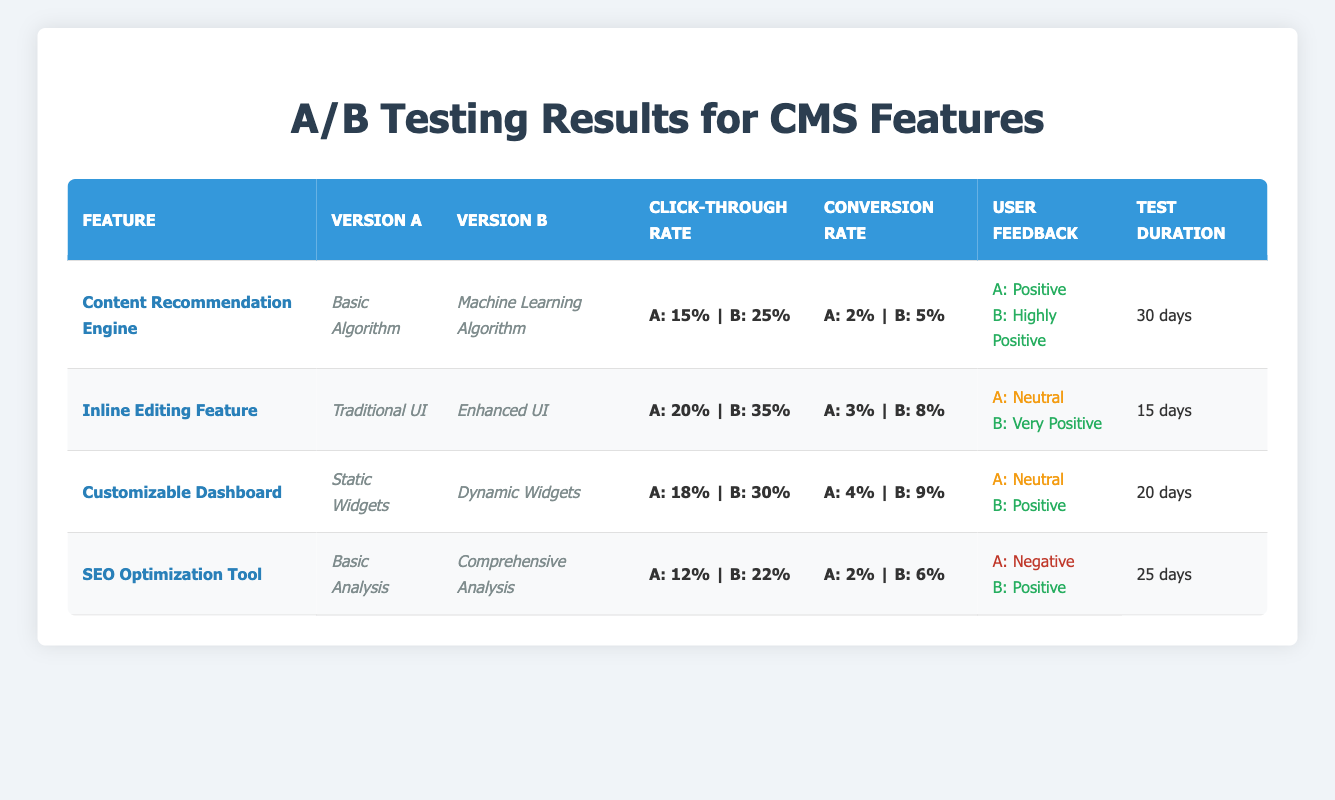What is the click-through rate for version B of the Content Recommendation Engine? The click-through rate for version B is listed directly in the table under the corresponding feature and version. For the Content Recommendation Engine, version B has a click-through rate of 25%.
Answer: 25% Which feature has the highest conversion rate for version A? By comparing the conversion rates for version A across all features in the table, the feature with the highest conversion rate is the Customizable Dashboard, which has a conversion rate of 4%.
Answer: Customizable Dashboard What is the average click-through rate for version A across all features? To find the average click-through rate for version A, sum the click-through rates: 15% + 20% + 18% + 12% = 65%. Then divide by the number of features, which is 4: 65% / 4 = 16.25%.
Answer: 16.25% Did version B of the Inline Editing Feature receive a positive user feedback? According to the table, version B of the Inline Editing Feature received "Very Positive" feedback, which is indeed classified as positive.
Answer: Yes What is the difference in the click-through rates between version A and version B for the SEO Optimization Tool? For the SEO Optimization Tool, the click-through rate for version A is 12% and for version B is 22%. The difference is calculated as 22% - 12% = 10%.
Answer: 10% Which version had a longer test duration, and by how many days? By examining the test durations, version A's longest test duration was 30 days (Content Recommendation Engine), and version B's longest was also 30 days. Since both versions have the same longest duration, there is no difference in length.
Answer: 0 days How many features received positive feedback in version B? Analyzing the feedback for version B, three features received feedback classified as positive: Content Recommendation Engine, Inline Editing Feature, and Customizable Dashboard. Therefore, three features received positive feedback.
Answer: 3 What is the maximum conversion rate for version B among the tested features? By reviewing the conversion rates for version B, the maximum value is found with the Inline Editing Feature, which has a conversion rate of 8%.
Answer: 8% What percentage of users provided negative feedback for version A? The table shows that only one feature (SEO Optimization Tool) received negative feedback for version A. Therefore, the percentage of users providing negative feedback can be inferred as 25% (1 out of 4 features).
Answer: 25% 